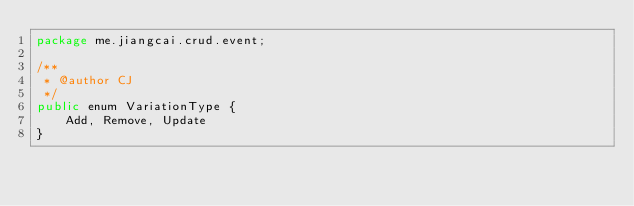<code> <loc_0><loc_0><loc_500><loc_500><_Java_>package me.jiangcai.crud.event;

/**
 * @author CJ
 */
public enum VariationType {
    Add, Remove, Update
}
</code> 